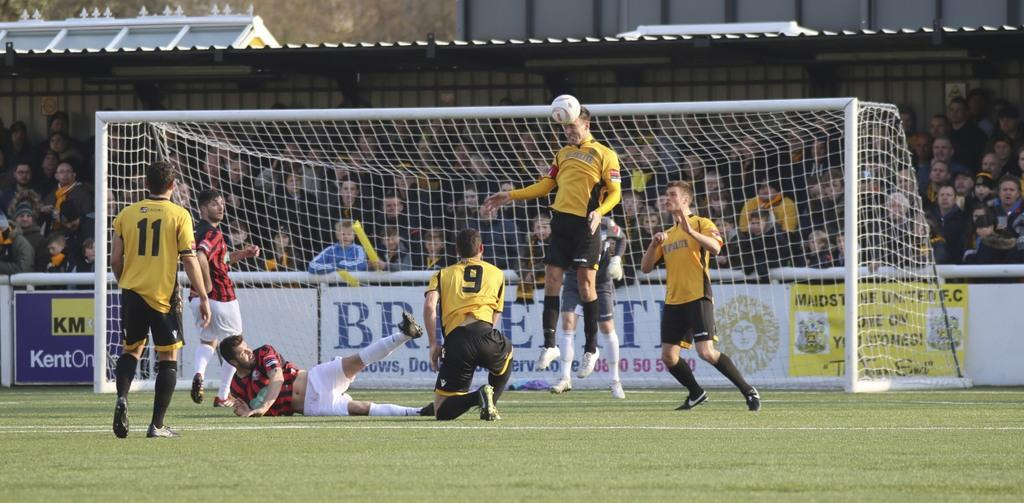What type of landscape is visible in the image? There is a field in the image. What activity are the seven people engaged in? They are sports players, which suggests they are playing a game or practicing a sport. What object is associated with the sport being played? There is a ball in the image. What type of structure can be seen in the background? There is a shed in the image. What are the people inside the shed doing? There is a group of people sitting inside the shed. How many rabbits can be seen hopping around in the field in the image? There are no rabbits visible in the image; it features a field with sports players and a shed. What type of plant is growing near the shed in the image? There is no cactus or any specific plant mentioned or visible in the image. 